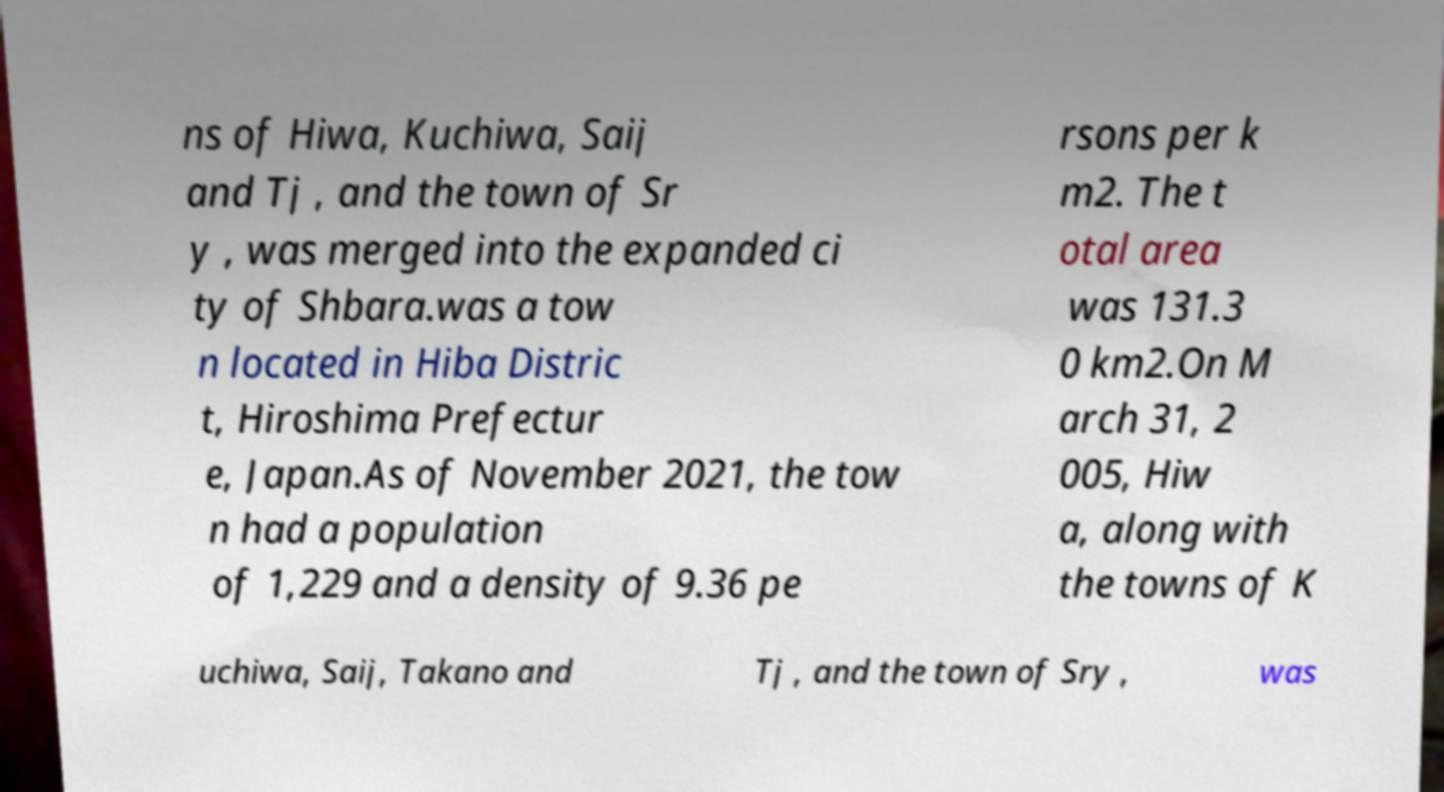Can you read and provide the text displayed in the image?This photo seems to have some interesting text. Can you extract and type it out for me? ns of Hiwa, Kuchiwa, Saij and Tj , and the town of Sr y , was merged into the expanded ci ty of Shbara.was a tow n located in Hiba Distric t, Hiroshima Prefectur e, Japan.As of November 2021, the tow n had a population of 1,229 and a density of 9.36 pe rsons per k m2. The t otal area was 131.3 0 km2.On M arch 31, 2 005, Hiw a, along with the towns of K uchiwa, Saij, Takano and Tj , and the town of Sry , was 